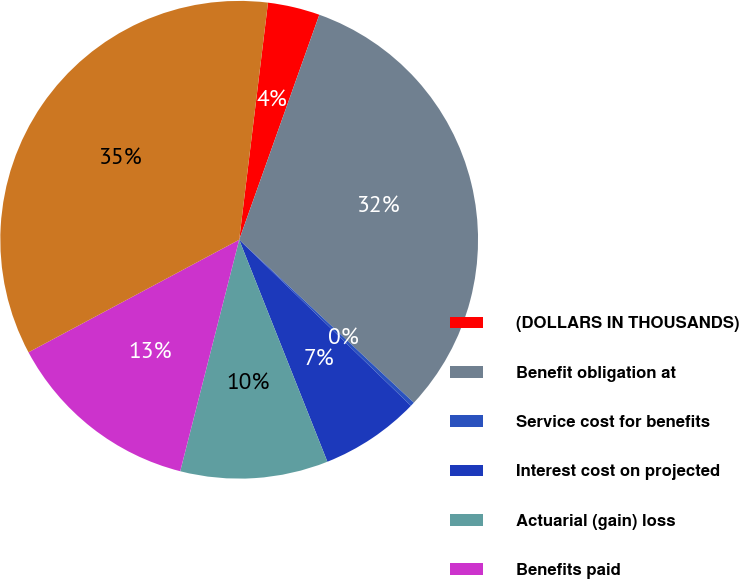Convert chart to OTSL. <chart><loc_0><loc_0><loc_500><loc_500><pie_chart><fcel>(DOLLARS IN THOUSANDS)<fcel>Benefit obligation at<fcel>Service cost for benefits<fcel>Interest cost on projected<fcel>Actuarial (gain) loss<fcel>Benefits paid<fcel>Benefit obligation at end of<nl><fcel>3.52%<fcel>31.5%<fcel>0.28%<fcel>6.75%<fcel>9.99%<fcel>13.22%<fcel>34.73%<nl></chart> 